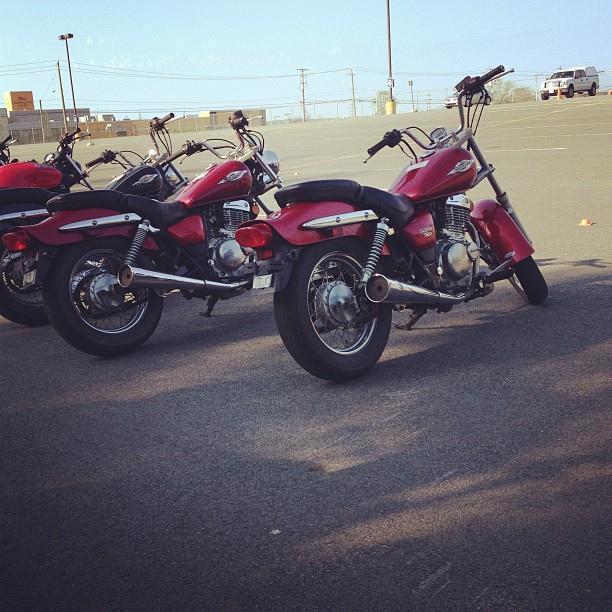How many motorcycles can be seen?
Give a very brief answer. 4. 